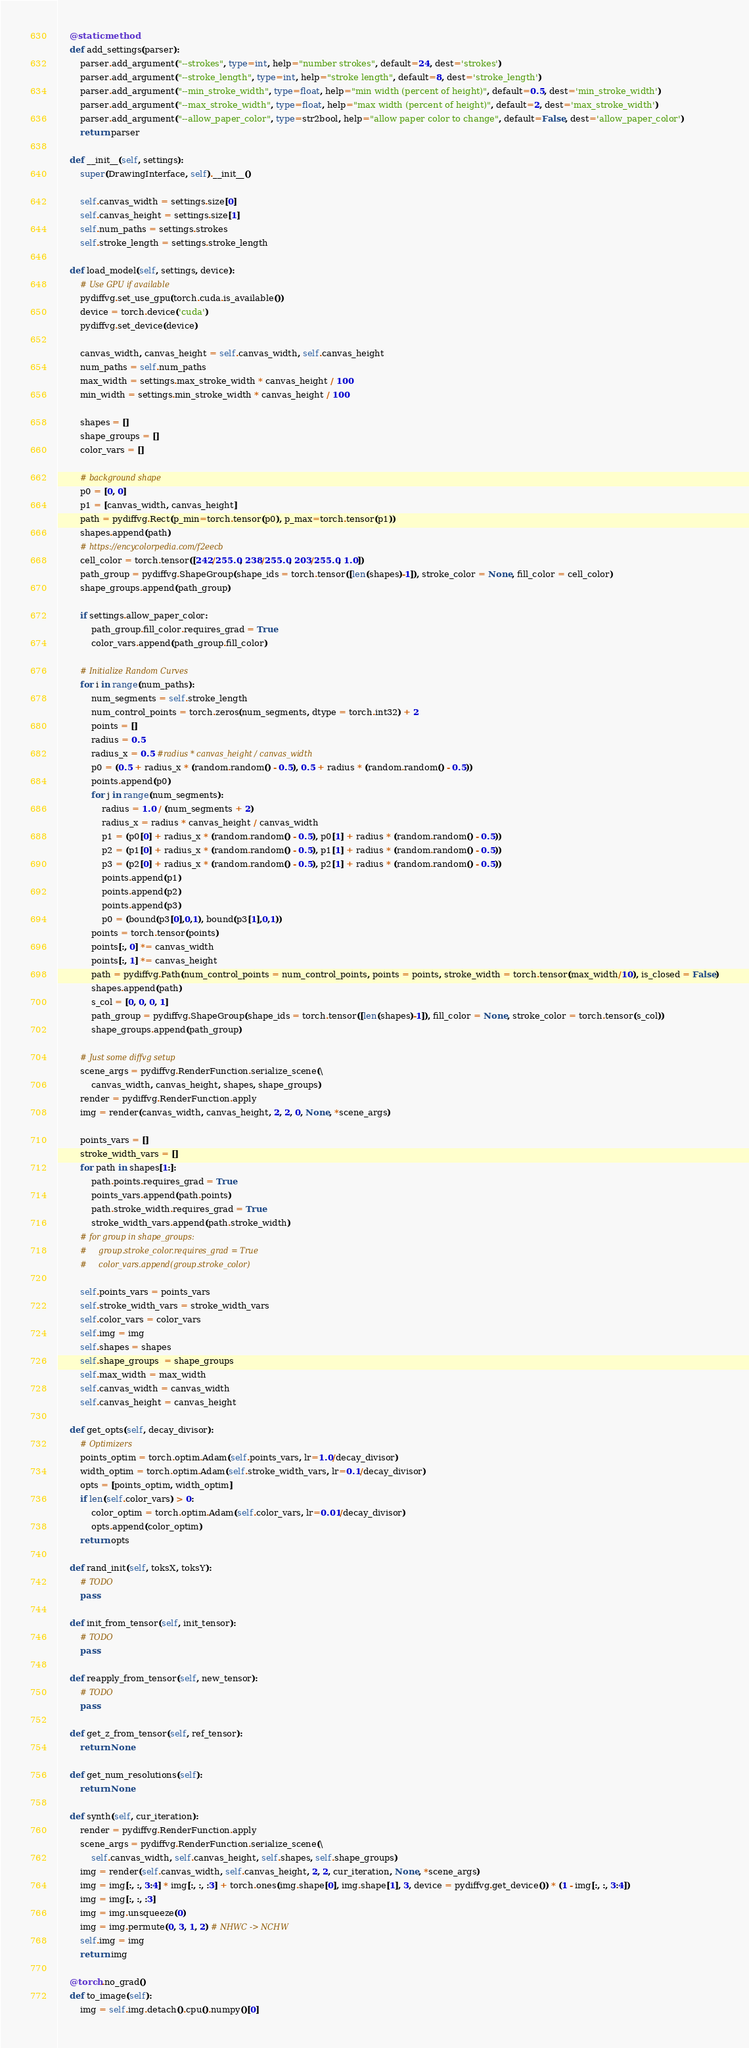<code> <loc_0><loc_0><loc_500><loc_500><_Python_>    @staticmethod
    def add_settings(parser):
        parser.add_argument("--strokes", type=int, help="number strokes", default=24, dest='strokes')
        parser.add_argument("--stroke_length", type=int, help="stroke length", default=8, dest='stroke_length')
        parser.add_argument("--min_stroke_width", type=float, help="min width (percent of height)", default=0.5, dest='min_stroke_width')
        parser.add_argument("--max_stroke_width", type=float, help="max width (percent of height)", default=2, dest='max_stroke_width')
        parser.add_argument("--allow_paper_color", type=str2bool, help="allow paper color to change", default=False, dest='allow_paper_color')
        return parser

    def __init__(self, settings):
        super(DrawingInterface, self).__init__()

        self.canvas_width = settings.size[0]
        self.canvas_height = settings.size[1]
        self.num_paths = settings.strokes
        self.stroke_length = settings.stroke_length

    def load_model(self, settings, device):
        # Use GPU if available
        pydiffvg.set_use_gpu(torch.cuda.is_available())
        device = torch.device('cuda')
        pydiffvg.set_device(device)

        canvas_width, canvas_height = self.canvas_width, self.canvas_height
        num_paths = self.num_paths
        max_width = settings.max_stroke_width * canvas_height / 100
        min_width = settings.min_stroke_width * canvas_height / 100

        shapes = []
        shape_groups = []
        color_vars = []

        # background shape
        p0 = [0, 0]
        p1 = [canvas_width, canvas_height]
        path = pydiffvg.Rect(p_min=torch.tensor(p0), p_max=torch.tensor(p1))
        shapes.append(path)
        # https://encycolorpedia.com/f2eecb
        cell_color = torch.tensor([242/255.0, 238/255.0, 203/255.0, 1.0])
        path_group = pydiffvg.ShapeGroup(shape_ids = torch.tensor([len(shapes)-1]), stroke_color = None, fill_color = cell_color)
        shape_groups.append(path_group)

        if settings.allow_paper_color:
            path_group.fill_color.requires_grad = True
            color_vars.append(path_group.fill_color)

        # Initialize Random Curves
        for i in range(num_paths):
            num_segments = self.stroke_length
            num_control_points = torch.zeros(num_segments, dtype = torch.int32) + 2
            points = []
            radius = 0.5
            radius_x = 0.5 #radius * canvas_height / canvas_width
            p0 = (0.5 + radius_x * (random.random() - 0.5), 0.5 + radius * (random.random() - 0.5))
            points.append(p0)
            for j in range(num_segments):
                radius = 1.0 / (num_segments + 2)
                radius_x = radius * canvas_height / canvas_width
                p1 = (p0[0] + radius_x * (random.random() - 0.5), p0[1] + radius * (random.random() - 0.5))
                p2 = (p1[0] + radius_x * (random.random() - 0.5), p1[1] + radius * (random.random() - 0.5))
                p3 = (p2[0] + radius_x * (random.random() - 0.5), p2[1] + radius * (random.random() - 0.5))
                points.append(p1)
                points.append(p2)
                points.append(p3)
                p0 = (bound(p3[0],0,1), bound(p3[1],0,1))
            points = torch.tensor(points)
            points[:, 0] *= canvas_width
            points[:, 1] *= canvas_height
            path = pydiffvg.Path(num_control_points = num_control_points, points = points, stroke_width = torch.tensor(max_width/10), is_closed = False)
            shapes.append(path)
            s_col = [0, 0, 0, 1]
            path_group = pydiffvg.ShapeGroup(shape_ids = torch.tensor([len(shapes)-1]), fill_color = None, stroke_color = torch.tensor(s_col))
            shape_groups.append(path_group)

        # Just some diffvg setup
        scene_args = pydiffvg.RenderFunction.serialize_scene(\
            canvas_width, canvas_height, shapes, shape_groups)
        render = pydiffvg.RenderFunction.apply
        img = render(canvas_width, canvas_height, 2, 2, 0, None, *scene_args)

        points_vars = []
        stroke_width_vars = []
        for path in shapes[1:]:
            path.points.requires_grad = True
            points_vars.append(path.points)
            path.stroke_width.requires_grad = True
            stroke_width_vars.append(path.stroke_width)
        # for group in shape_groups:
        #     group.stroke_color.requires_grad = True
        #     color_vars.append(group.stroke_color)

        self.points_vars = points_vars
        self.stroke_width_vars = stroke_width_vars
        self.color_vars = color_vars
        self.img = img
        self.shapes = shapes 
        self.shape_groups  = shape_groups
        self.max_width = max_width
        self.canvas_width = canvas_width
        self.canvas_height = canvas_height

    def get_opts(self, decay_divisor):
        # Optimizers
        points_optim = torch.optim.Adam(self.points_vars, lr=1.0/decay_divisor)
        width_optim = torch.optim.Adam(self.stroke_width_vars, lr=0.1/decay_divisor)
        opts = [points_optim, width_optim]
        if len(self.color_vars) > 0:
            color_optim = torch.optim.Adam(self.color_vars, lr=0.01/decay_divisor)
            opts.append(color_optim)
        return opts

    def rand_init(self, toksX, toksY):
        # TODO
        pass

    def init_from_tensor(self, init_tensor):
        # TODO
        pass

    def reapply_from_tensor(self, new_tensor):
        # TODO
        pass

    def get_z_from_tensor(self, ref_tensor):
        return None

    def get_num_resolutions(self):
        return None

    def synth(self, cur_iteration):
        render = pydiffvg.RenderFunction.apply
        scene_args = pydiffvg.RenderFunction.serialize_scene(\
            self.canvas_width, self.canvas_height, self.shapes, self.shape_groups)
        img = render(self.canvas_width, self.canvas_height, 2, 2, cur_iteration, None, *scene_args)
        img = img[:, :, 3:4] * img[:, :, :3] + torch.ones(img.shape[0], img.shape[1], 3, device = pydiffvg.get_device()) * (1 - img[:, :, 3:4])
        img = img[:, :, :3]
        img = img.unsqueeze(0)
        img = img.permute(0, 3, 1, 2) # NHWC -> NCHW
        self.img = img
        return img

    @torch.no_grad()
    def to_image(self):
        img = self.img.detach().cpu().numpy()[0]</code> 